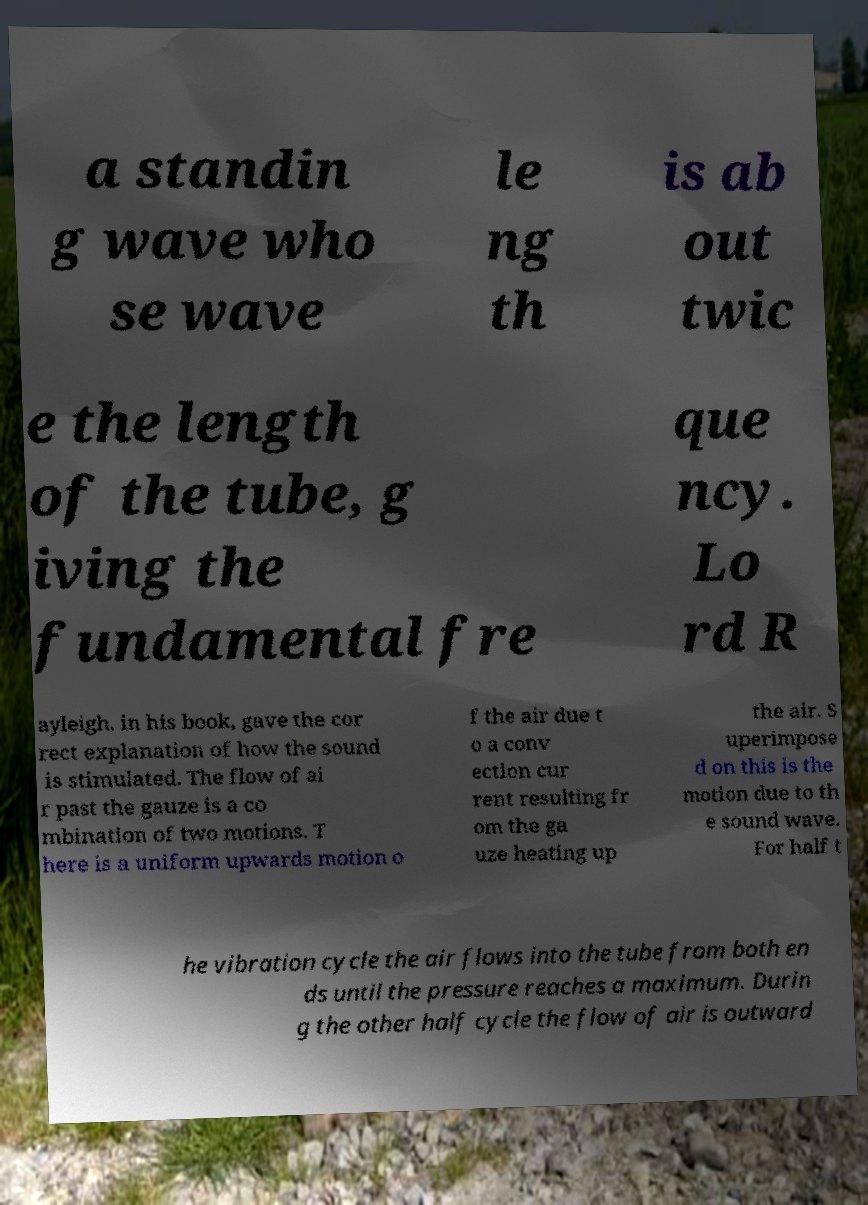Could you assist in decoding the text presented in this image and type it out clearly? a standin g wave who se wave le ng th is ab out twic e the length of the tube, g iving the fundamental fre que ncy. Lo rd R ayleigh, in his book, gave the cor rect explanation of how the sound is stimulated. The flow of ai r past the gauze is a co mbination of two motions. T here is a uniform upwards motion o f the air due t o a conv ection cur rent resulting fr om the ga uze heating up the air. S uperimpose d on this is the motion due to th e sound wave. For half t he vibration cycle the air flows into the tube from both en ds until the pressure reaches a maximum. Durin g the other half cycle the flow of air is outward 